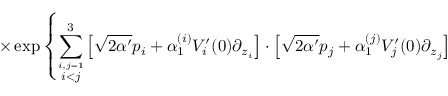Convert formula to latex. <formula><loc_0><loc_0><loc_500><loc_500>\times \exp \left \{ \sum _ { \stackrel { i , j = 1 } { i < j } } ^ { 3 } \left [ \sqrt { 2 \alpha ^ { \prime } } p _ { i } + \alpha _ { 1 } ^ { ( i ) } V _ { i } ^ { \prime } ( 0 ) \partial _ { z _ { i } } \right ] \cdot \left [ \sqrt { 2 \alpha ^ { \prime } } p _ { j } + \alpha _ { 1 } ^ { ( j ) } V _ { j } ^ { \prime } ( 0 ) \partial _ { z _ { j } } \right ]</formula> 